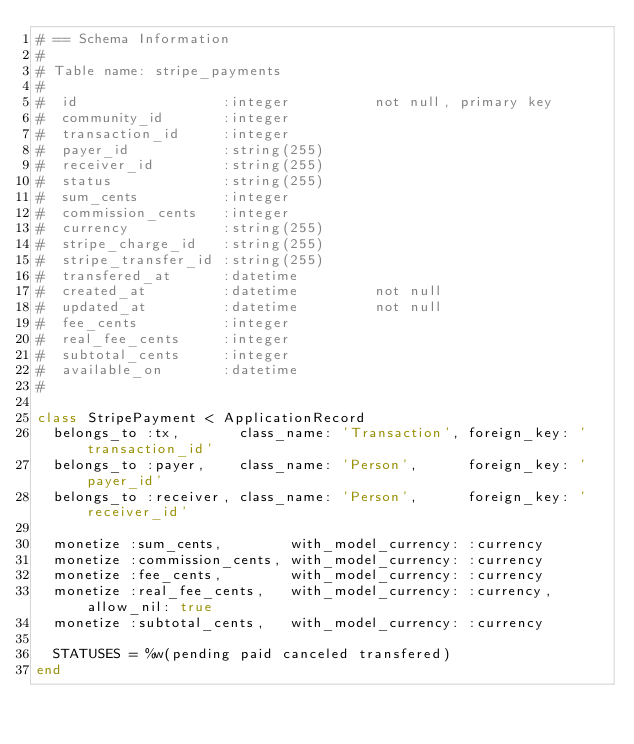Convert code to text. <code><loc_0><loc_0><loc_500><loc_500><_Ruby_># == Schema Information
#
# Table name: stripe_payments
#
#  id                 :integer          not null, primary key
#  community_id       :integer
#  transaction_id     :integer
#  payer_id           :string(255)
#  receiver_id        :string(255)
#  status             :string(255)
#  sum_cents          :integer
#  commission_cents   :integer
#  currency           :string(255)
#  stripe_charge_id   :string(255)
#  stripe_transfer_id :string(255)
#  transfered_at      :datetime
#  created_at         :datetime         not null
#  updated_at         :datetime         not null
#  fee_cents          :integer
#  real_fee_cents     :integer
#  subtotal_cents     :integer
#  available_on       :datetime
#

class StripePayment < ApplicationRecord
  belongs_to :tx,       class_name: 'Transaction', foreign_key: 'transaction_id'
  belongs_to :payer,    class_name: 'Person',      foreign_key: 'payer_id'
  belongs_to :receiver, class_name: 'Person',      foreign_key: 'receiver_id'

  monetize :sum_cents,        with_model_currency: :currency
  monetize :commission_cents, with_model_currency: :currency
  monetize :fee_cents,        with_model_currency: :currency
  monetize :real_fee_cents,   with_model_currency: :currency, allow_nil: true
  monetize :subtotal_cents,   with_model_currency: :currency

  STATUSES = %w(pending paid canceled transfered)
end
</code> 